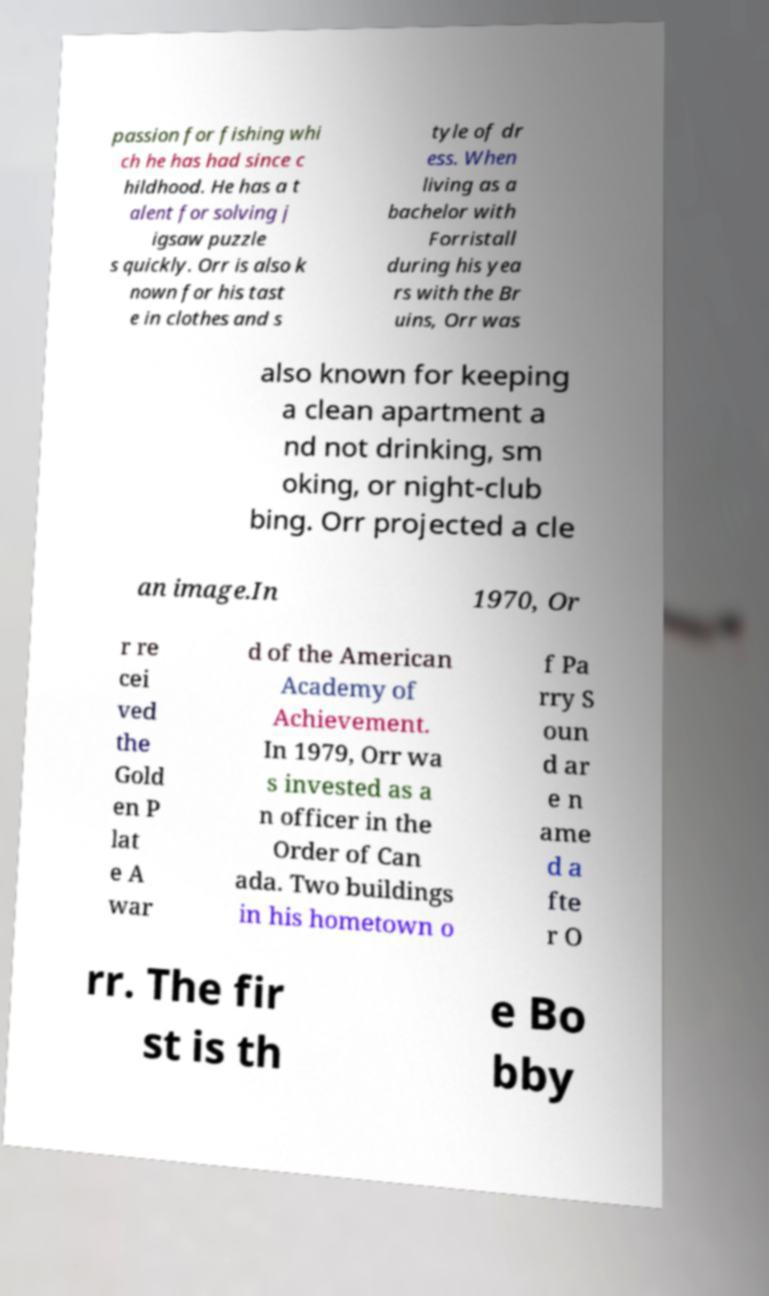Could you extract and type out the text from this image? passion for fishing whi ch he has had since c hildhood. He has a t alent for solving j igsaw puzzle s quickly. Orr is also k nown for his tast e in clothes and s tyle of dr ess. When living as a bachelor with Forristall during his yea rs with the Br uins, Orr was also known for keeping a clean apartment a nd not drinking, sm oking, or night-club bing. Orr projected a cle an image.In 1970, Or r re cei ved the Gold en P lat e A war d of the American Academy of Achievement. In 1979, Orr wa s invested as a n officer in the Order of Can ada. Two buildings in his hometown o f Pa rry S oun d ar e n ame d a fte r O rr. The fir st is th e Bo bby 